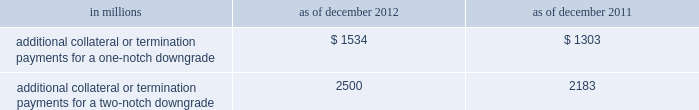Management 2019s discussion and analysis we believe our credit ratings are primarily based on the credit rating agencies 2019 assessment of : 2030 our liquidity , market , credit and operational risk management practices ; 2030 the level and variability of our earnings ; 2030 our capital base ; 2030 our franchise , reputation and management ; 2030 our corporate governance ; and 2030 the external operating environment , including the assumed level of government support .
Certain of the firm 2019s derivatives have been transacted under bilateral agreements with counterparties who may require us to post collateral or terminate the transactions based on changes in our credit ratings .
We assess the impact of these bilateral agreements by determining the collateral or termination payments that would occur assuming a downgrade by all rating agencies .
A downgrade by any one rating agency , depending on the agency 2019s relative ratings of the firm at the time of the downgrade , may have an impact which is comparable to the impact of a downgrade by all rating agencies .
We allocate a portion of our gce to ensure we would be able to make the additional collateral or termination payments that may be required in the event of a two-notch reduction in our long-term credit ratings , as well as collateral that has not been called by counterparties , but is available to them .
The table below presents the additional collateral or termination payments that could have been called at the reporting date by counterparties in the event of a one-notch and two-notch downgrade in our credit ratings. .
In millions 2012 2011 additional collateral or termination payments for a one-notch downgrade $ 1534 $ 1303 additional collateral or termination payments for a two-notch downgrade 2500 2183 cash flows as a global financial institution , our cash flows are complex and bear little relation to our net earnings and net assets .
Consequently , we believe that traditional cash flow analysis is less meaningful in evaluating our liquidity position than the excess liquidity and asset-liability management policies described above .
Cash flow analysis may , however , be helpful in highlighting certain macro trends and strategic initiatives in our businesses .
Year ended december 2012 .
Our cash and cash equivalents increased by $ 16.66 billion to $ 72.67 billion at the end of 2012 .
We generated $ 9.14 billion in net cash from operating and investing activities .
We generated $ 7.52 billion in net cash from financing activities from an increase in bank deposits , partially offset by net repayments of unsecured and secured long-term borrowings .
Year ended december 2011 .
Our cash and cash equivalents increased by $ 16.22 billion to $ 56.01 billion at the end of 2011 .
We generated $ 23.13 billion in net cash from operating and investing activities .
We used net cash of $ 6.91 billion for financing activities , primarily for repurchases of our series g preferred stock and common stock , partially offset by an increase in bank deposits .
Year ended december 2010 .
Our cash and cash equivalents increased by $ 1.50 billion to $ 39.79 billion at the end of 2010 .
We generated $ 7.84 billion in net cash from financing activities primarily from net proceeds from issuances of short-term secured financings .
We used net cash of $ 6.34 billion for operating and investing activities , primarily to fund an increase in securities purchased under agreements to resell and an increase in cash and securities segregated for regulatory and other purposes , partially offset by cash generated from a decrease in securities borrowed .
Goldman sachs 2012 annual report 87 .
What is the percentage of additional collateral or termination payments for a two-notch downgrade over additional collateral or termination payments for a one-notch downgrade for 2011? 
Computations: ((2183 - 1303) / 1303)
Answer: 0.67536. 